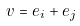<formula> <loc_0><loc_0><loc_500><loc_500>v = e _ { i } + e _ { j }</formula> 